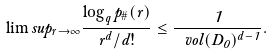<formula> <loc_0><loc_0><loc_500><loc_500>\lim s u p _ { r \to \infty } \frac { \log _ { q } p _ { \# } ( r ) } { r ^ { d } / d ! } \leq \frac { 1 } { \ v o l ( D _ { 0 } ) ^ { d - 1 } } .</formula> 